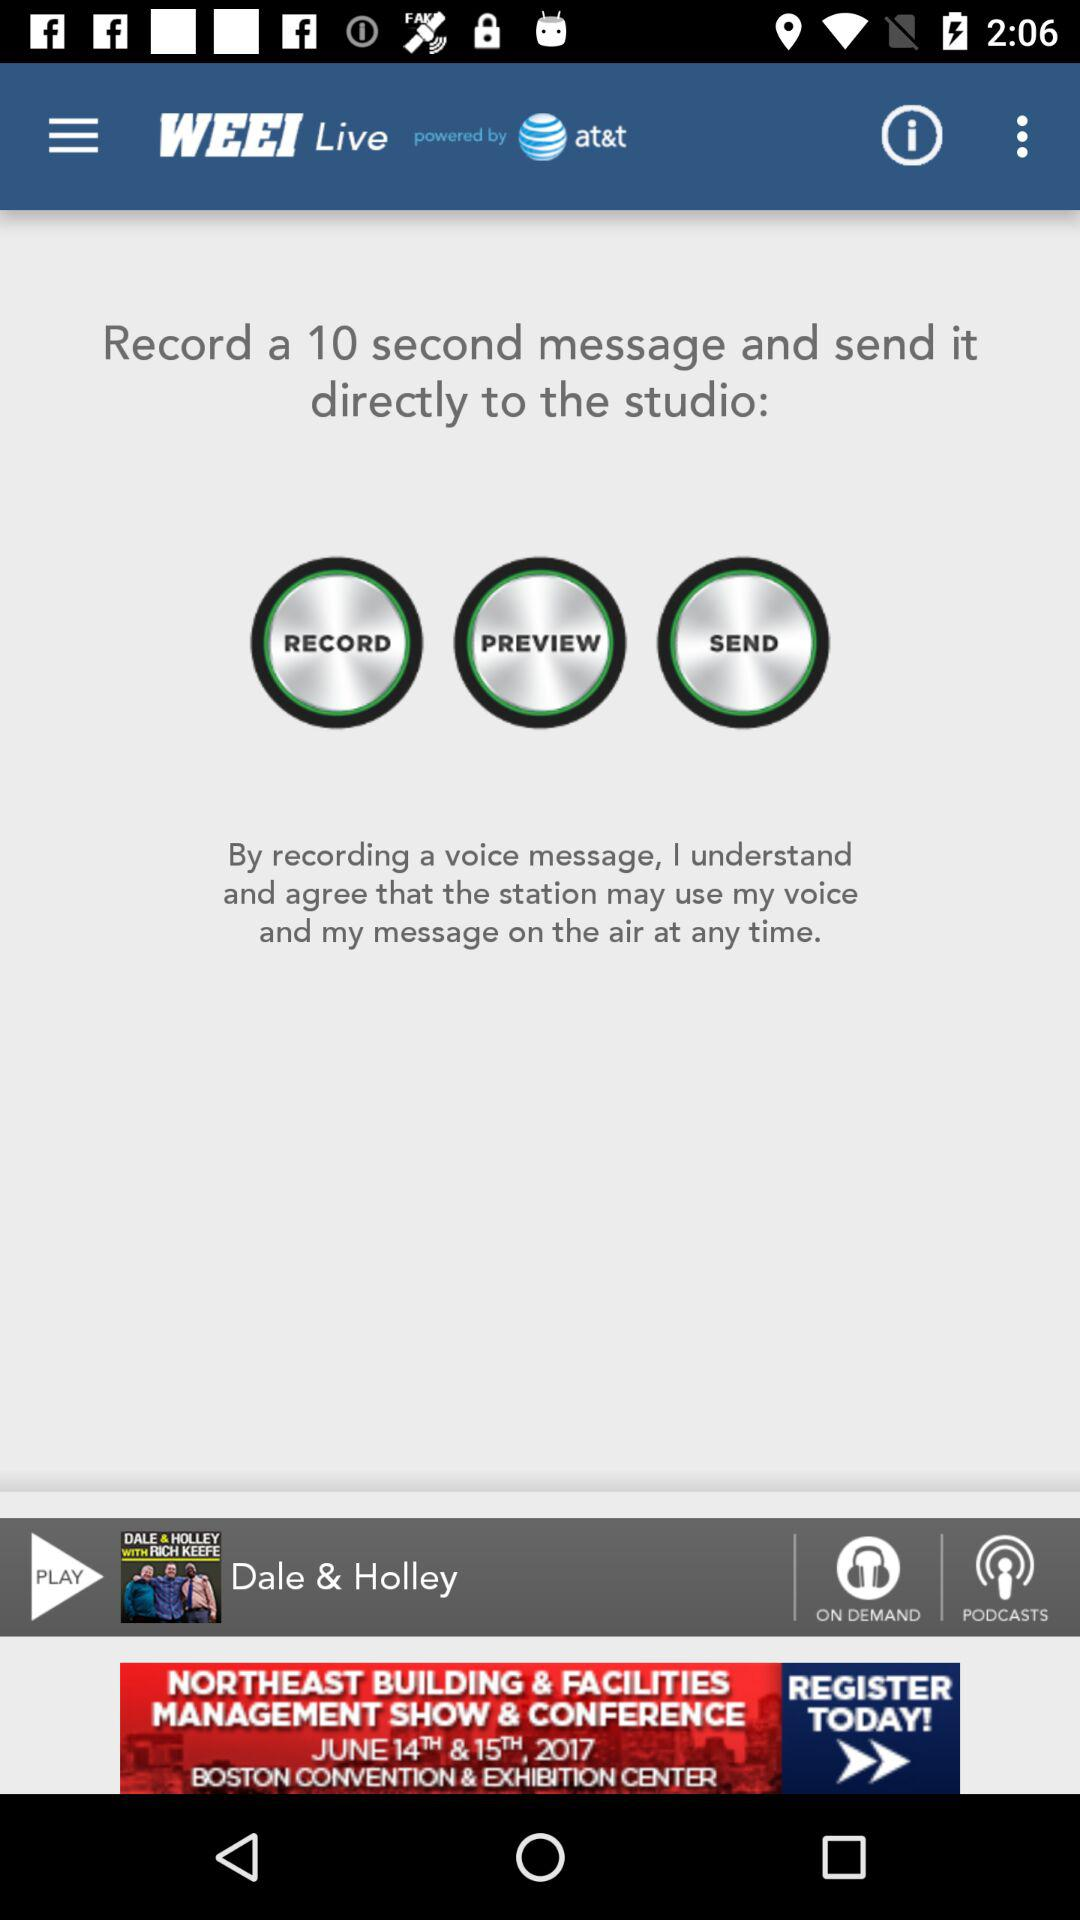Which show was last played? The show that was last played was "DALE & HOLLEY WITH RICH KEEFE". 